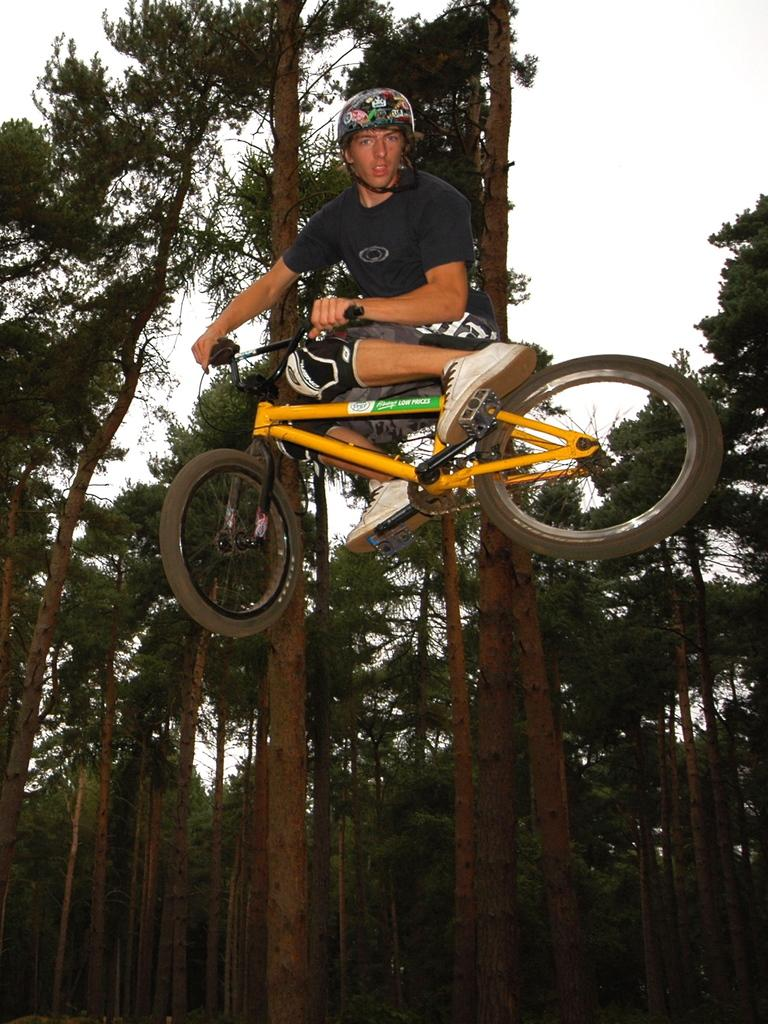What is the person in the image doing? The person is sitting on a bicycle. What is unusual about the bicycle's position in the image? The bicycle appears to be in the air. What can be seen in the background of the image? There are trees and the sky visible in the background. What type of bean is being used as a prop on the stage in the image? There is no bean or stage present in the image; it features a person sitting on a bicycle in the air. How many fingers can be seen pointing at the bicycle in the image? There are no fingers or indication of pointing in the image. 